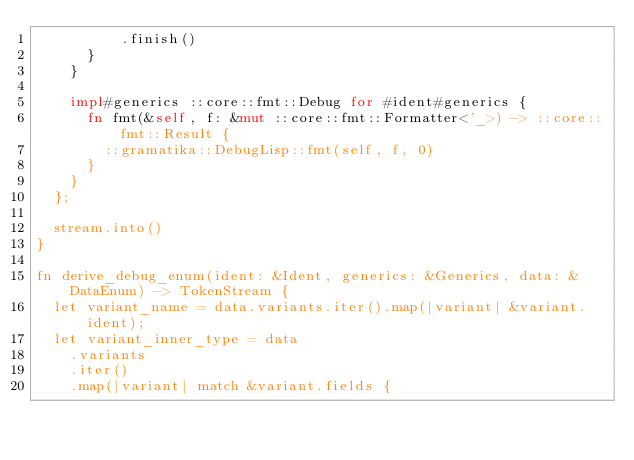<code> <loc_0><loc_0><loc_500><loc_500><_Rust_>					.finish()
			}
		}

		impl#generics ::core::fmt::Debug for #ident#generics {
			fn fmt(&self, f: &mut ::core::fmt::Formatter<'_>) -> ::core::fmt::Result {
				::gramatika::DebugLisp::fmt(self, f, 0)
			}
		}
	};

	stream.into()
}

fn derive_debug_enum(ident: &Ident, generics: &Generics, data: &DataEnum) -> TokenStream {
	let variant_name = data.variants.iter().map(|variant| &variant.ident);
	let variant_inner_type = data
		.variants
		.iter()
		.map(|variant| match &variant.fields {</code> 